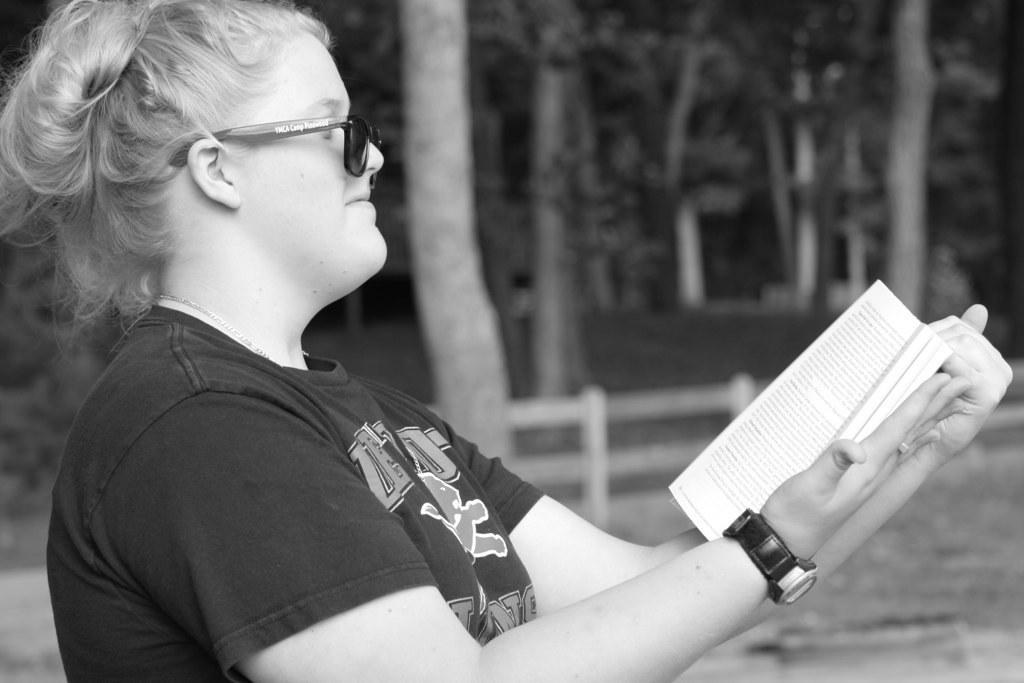Can you describe this image briefly? In the foreground I can see a woman is holding a book in hand. In the background I can see a fence and trees. This image is taken during night. 